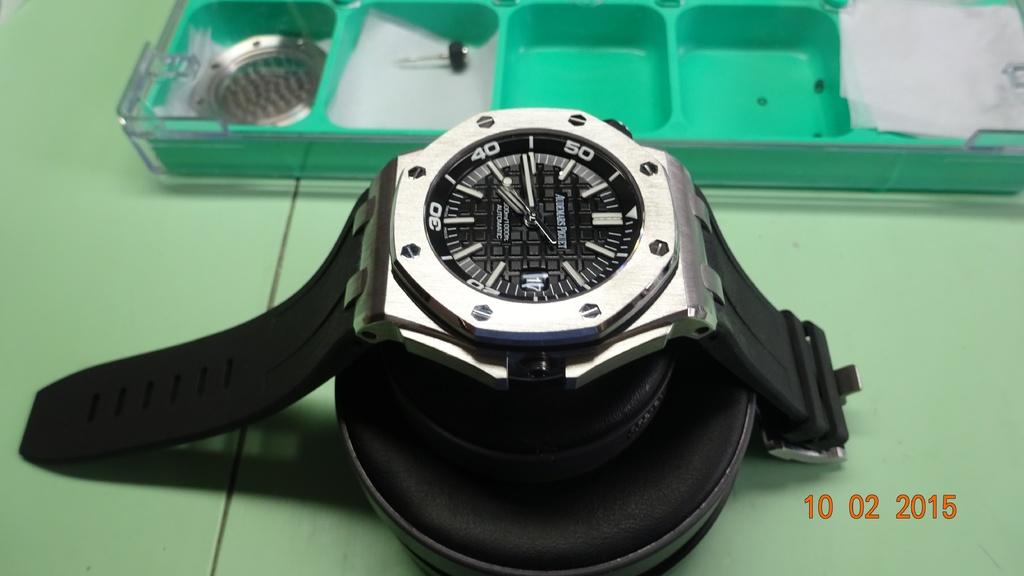When was this photo taken?
Your response must be concise. 10 02 2015. What is the name in red?
Ensure brevity in your answer.  Unanswerable. 